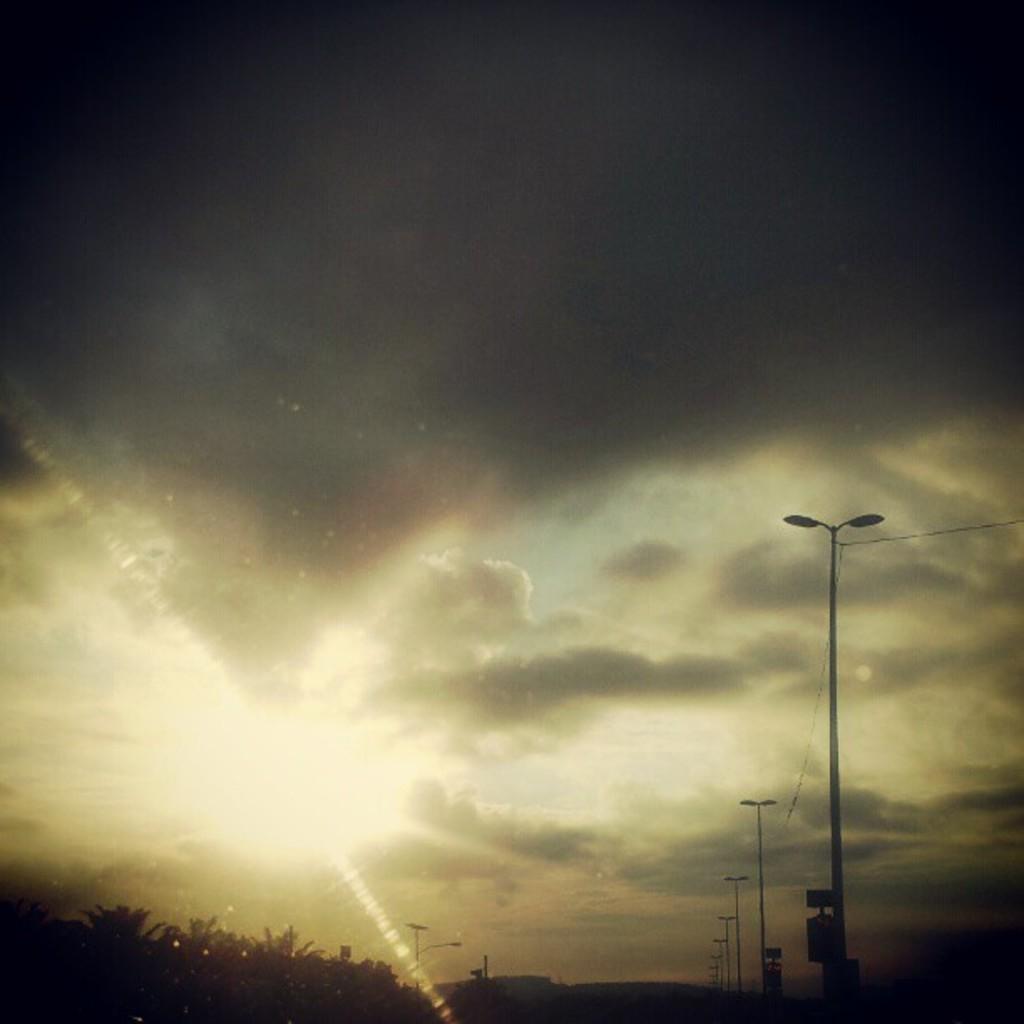In one or two sentences, can you explain what this image depicts? In this image, we can see some poles with wires. We can see some trees. We can see some boards. We can see the sky with clouds. 